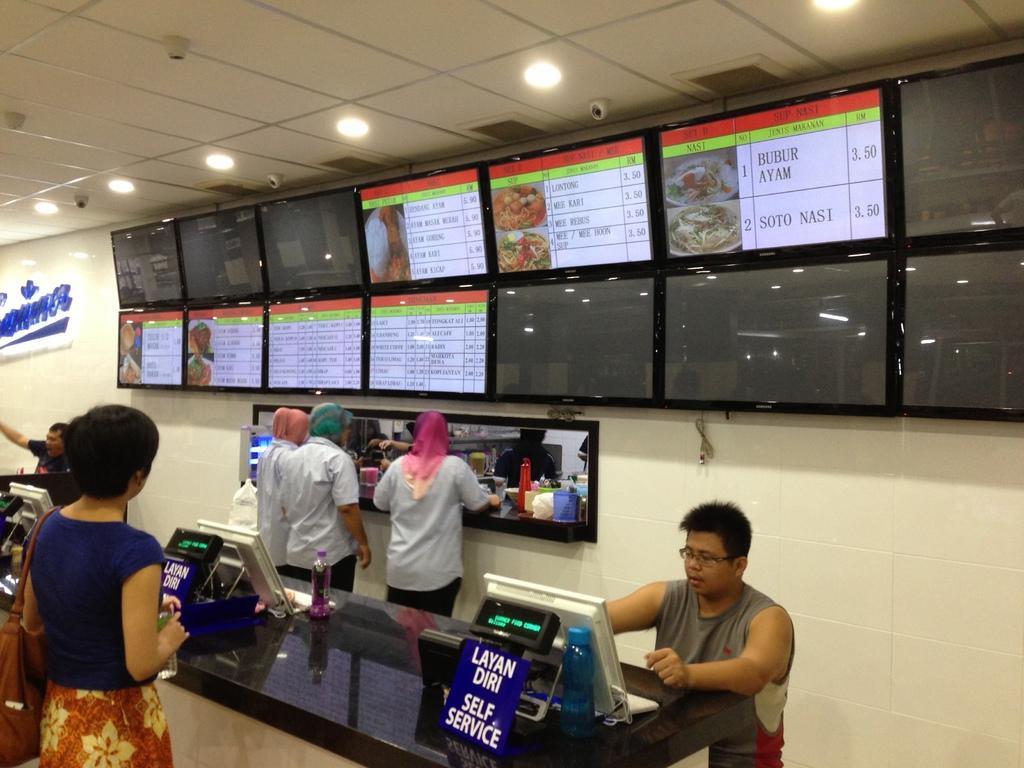In one or two sentences, can you explain what this image depicts? In this image we can see people and there is a countertop. There are computers, bottles and boards placed on the counter top. In the background there is a counter and we can see some objects. There are lights and we can see screens placed on the wall. 